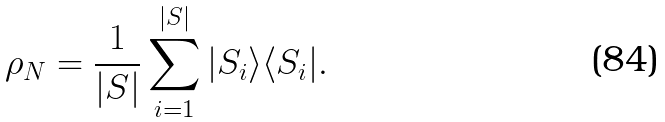<formula> <loc_0><loc_0><loc_500><loc_500>\rho _ { N } = \frac { 1 } { | S | } \sum _ { i = 1 } ^ { | S | } | S _ { i } \rangle \langle S _ { i } | .</formula> 